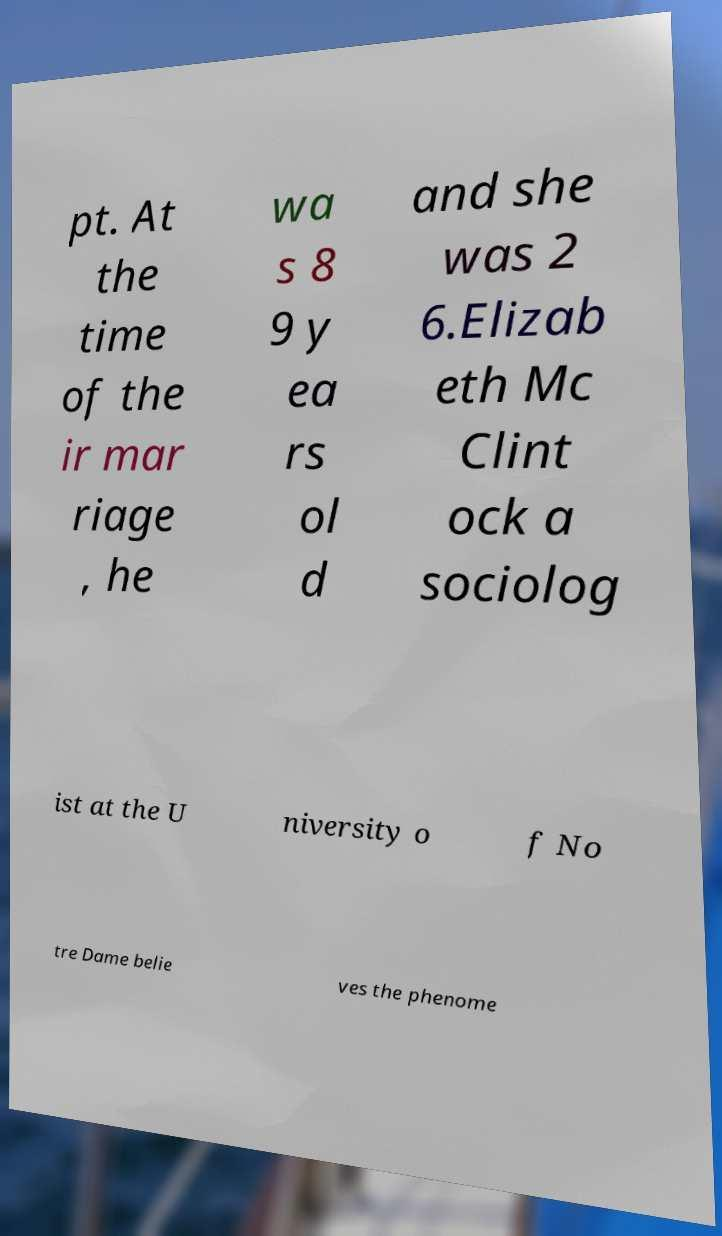I need the written content from this picture converted into text. Can you do that? pt. At the time of the ir mar riage , he wa s 8 9 y ea rs ol d and she was 2 6.Elizab eth Mc Clint ock a sociolog ist at the U niversity o f No tre Dame belie ves the phenome 